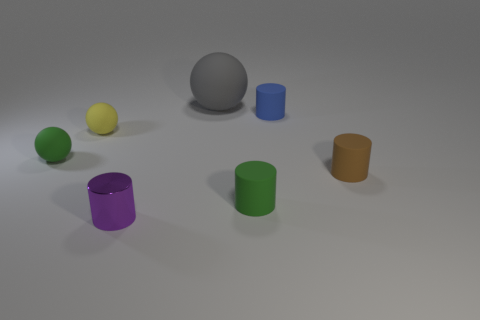How big is the green rubber thing that is to the right of the purple cylinder?
Make the answer very short. Small. Does the green thing that is on the left side of the metal thing have the same size as the tiny yellow matte sphere?
Provide a short and direct response. Yes. Are there any other things that have the same color as the large object?
Give a very brief answer. No. What is the shape of the blue thing?
Ensure brevity in your answer.  Cylinder. What number of cylinders are both in front of the small green matte sphere and behind the yellow matte sphere?
Keep it short and to the point. 0. Is the big rubber ball the same color as the metallic object?
Offer a terse response. No. There is a green thing that is the same shape as the blue thing; what is it made of?
Give a very brief answer. Rubber. Is there anything else that has the same material as the tiny blue thing?
Ensure brevity in your answer.  Yes. Is the number of small yellow balls that are to the left of the small yellow matte sphere the same as the number of gray rubber things on the right side of the tiny purple cylinder?
Your answer should be compact. No. Does the small purple cylinder have the same material as the green cylinder?
Keep it short and to the point. No. 